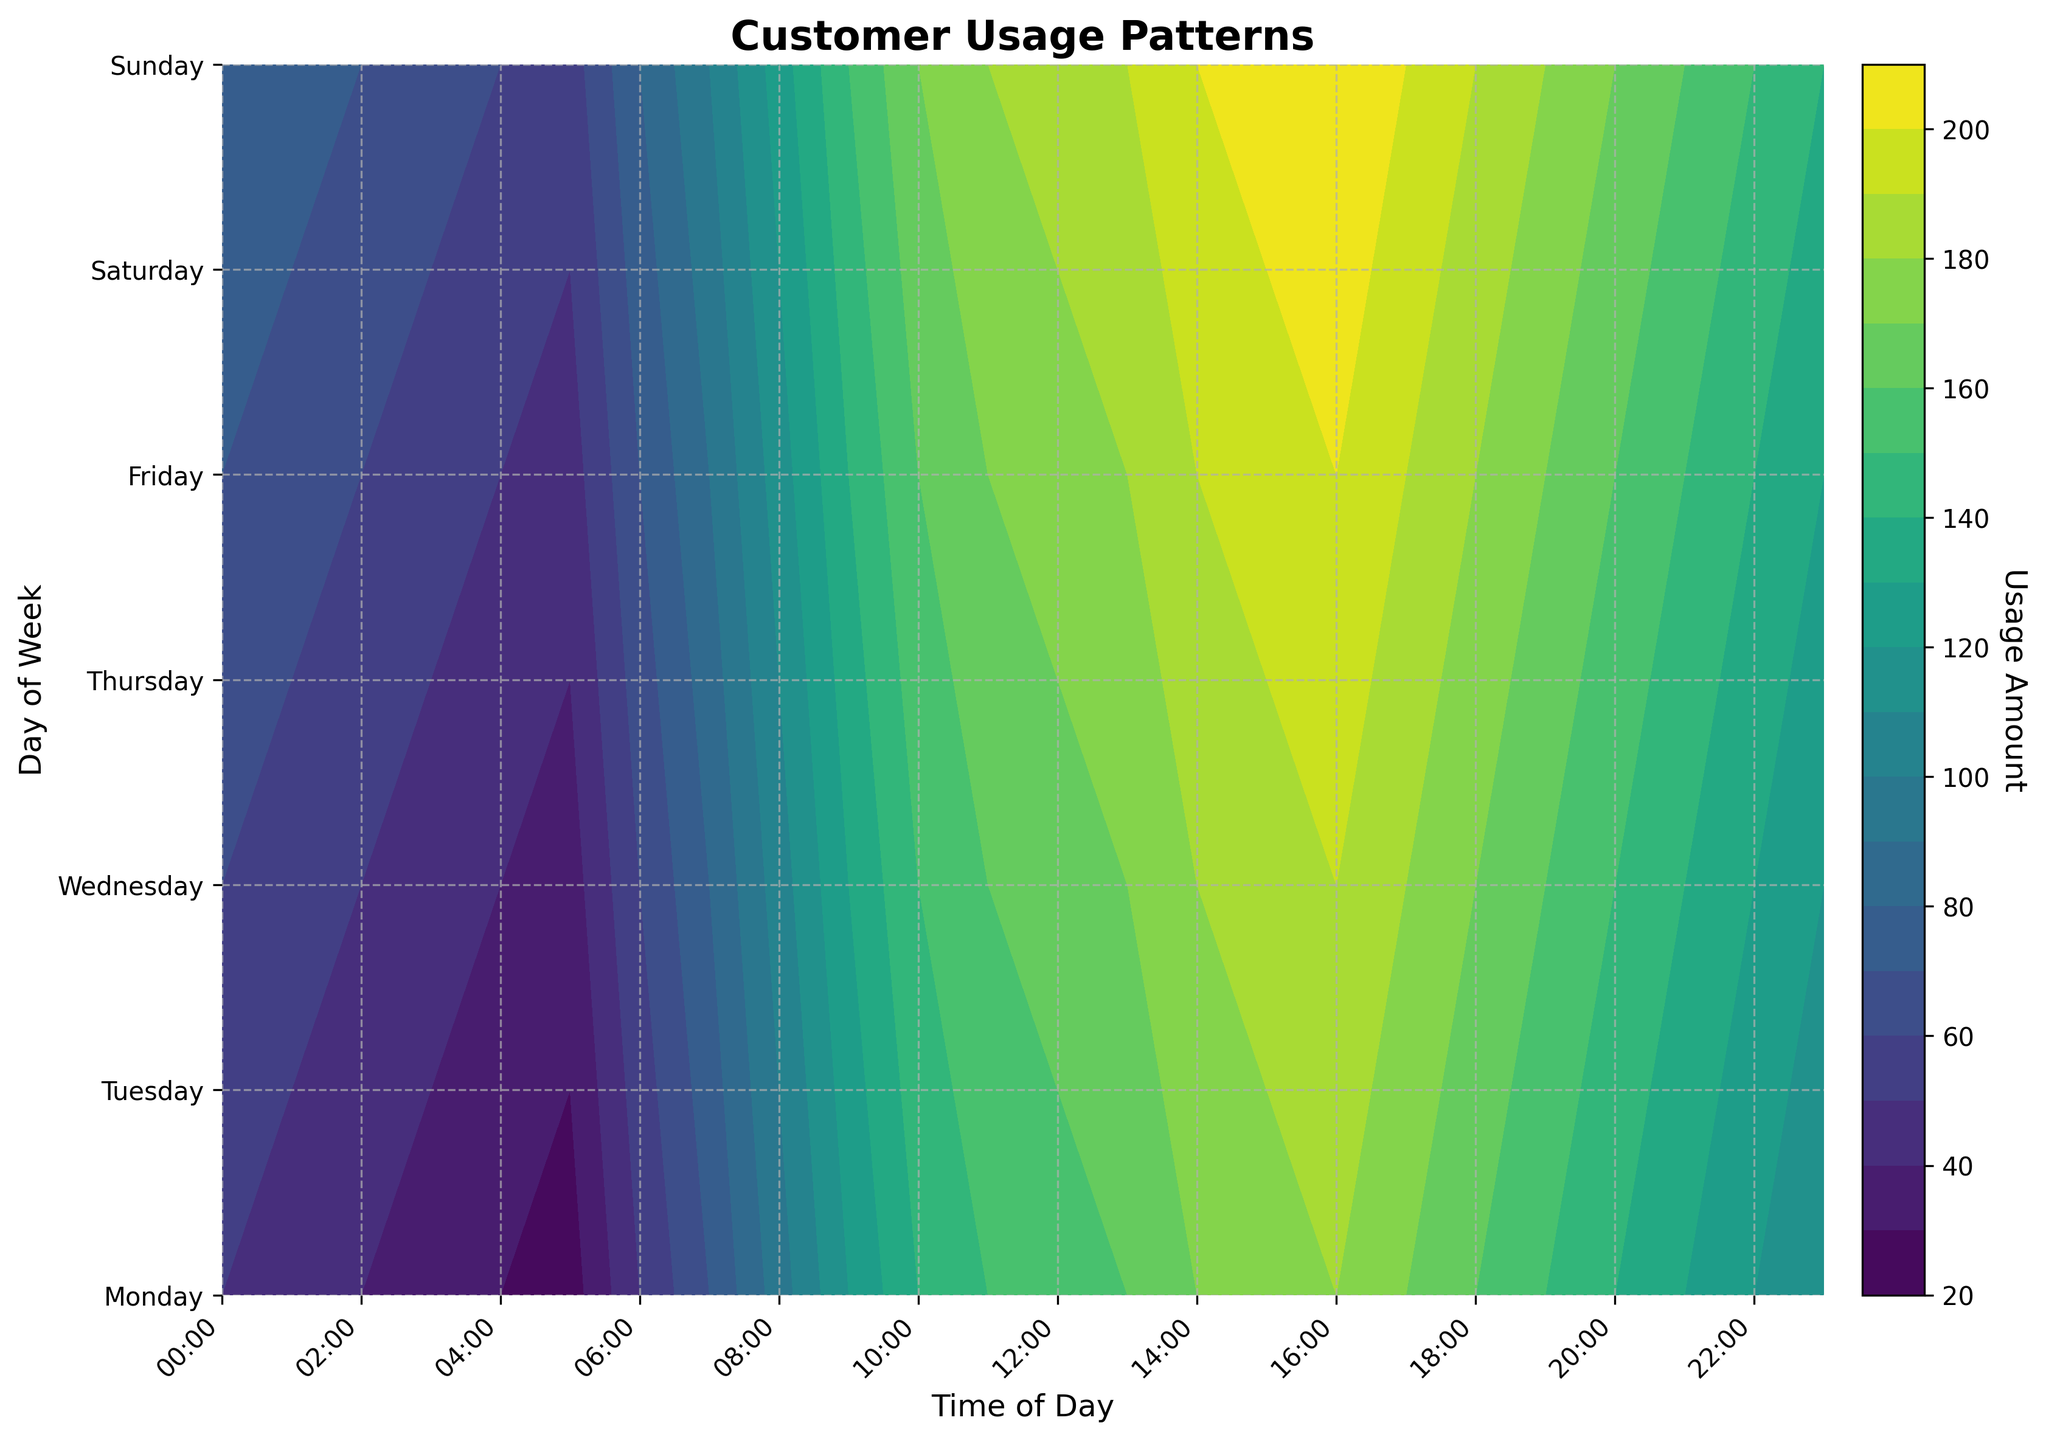Which day has the highest peak usage amount? From the contour plot, look for the day with the highest contour level. This is where the darkest color will be found.
Answer: Sunday What time of day generally shows the highest usage across the week? Identify the time period across all days that consistently shows higher usage, which will appear as darker color bands in the contour plot.
Answer: 15:00-16:00 Which day has the least usage in the early morning (00:00-06:00)? Examine the leftmost section of the contour plot for each day and compare the contour levels. The lightest color in this section signifies the lowest usage.
Answer: Monday At what time does Monday's usage peak? Search for the maximum contour level on the Monday row, which will be the darkest section along that day's row.
Answer: 16:00-17:00 How does the peak usage time on Saturday compare to that on Friday? Find the darkest sections on both Friday and Saturday rows and compare their time of occurrence. Both days will have a higher usage but at slightly different times.
Answer: Friday: 16:00-17:00, Saturday: 15:00-16:00 During what time period does Wednesday experience consistent usage above 175? Identify the dark regions along the Wednesday row where the usage remains above 175 for an extended period.
Answer: Between 14:00 and 18:00 Which day shows a relatively even distribution of usage throughout its entire day? A day with even contour coloring spanning horizontally suggests a more consistent distribution of usage throughout the day.
Answer: Monday When comparing weekends to weekdays, which days generally show higher peak usage? Compare the darkest sections present during the weekend (Saturday and Sunday) with those of the weekdays to identify any marked differences in peak usage.
Answer: Weekends What is the general trend of usage from 07:00 to 19:00 on weekdays? Observe the contour levels from 07:00 to 19:00 for Monday through Friday to discern if there is an upward, downward, or consistent pattern.
Answer: Increasing till afternoon, then decreasing Which day shows the smallest variation in usage throughout the day? Identify the contour plot row with the least variance in color darkness, signifying minimal changes in usage.
Answer: Monday 